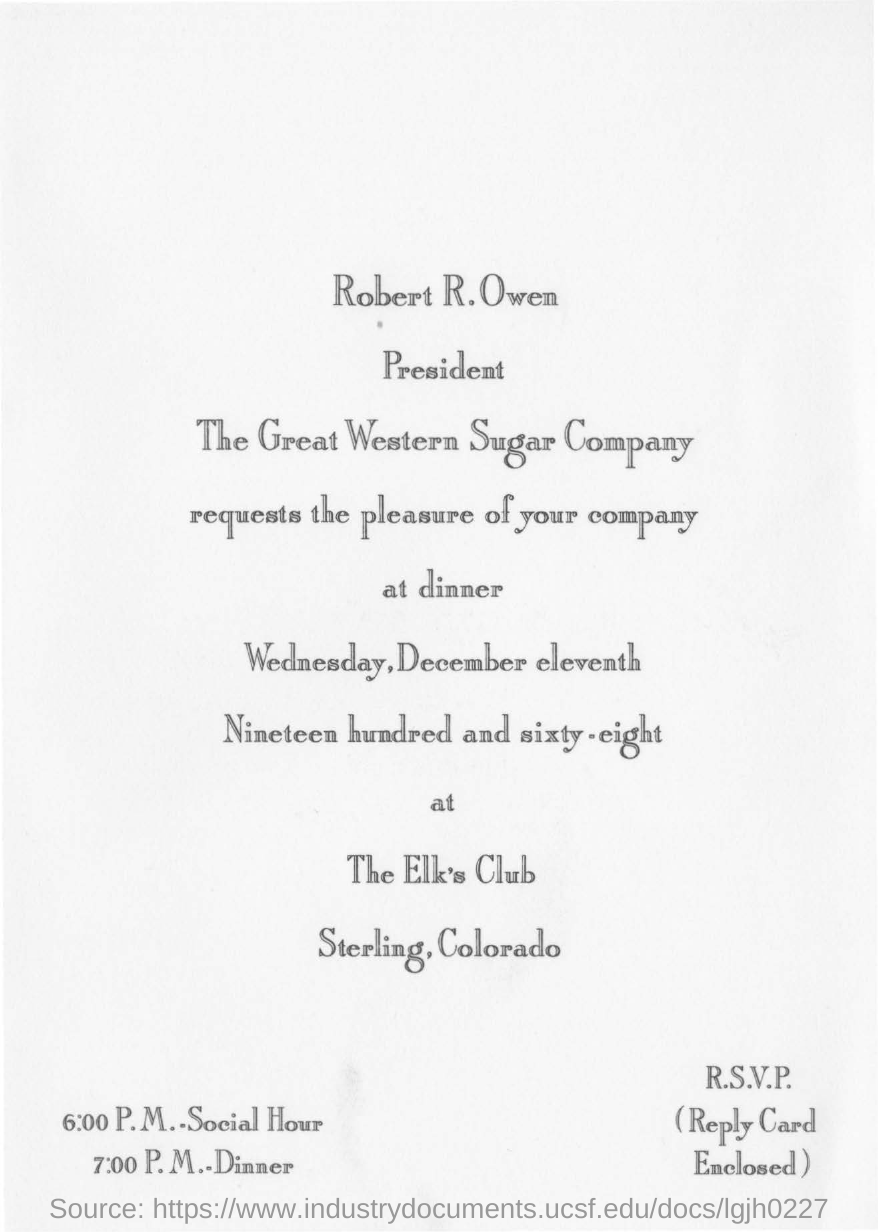Point out several critical features in this image. The dinner was scheduled for 7:00 P.M. The dinner date in question is on Wednesday, December 11th, 1968. The venue of the dinner is the Elk's Club in Sterling, Colorado. Social Hour is expected to begin at 6:00 P.M. The letter is about dinner. 